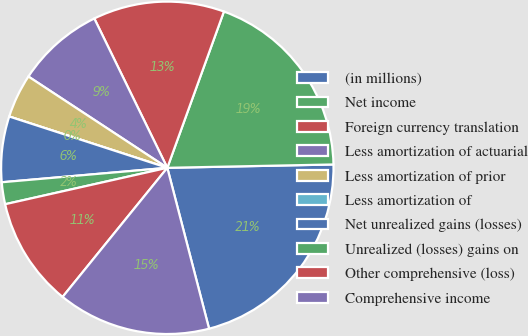Convert chart to OTSL. <chart><loc_0><loc_0><loc_500><loc_500><pie_chart><fcel>(in millions)<fcel>Net income<fcel>Foreign currency translation<fcel>Less amortization of actuarial<fcel>Less amortization of prior<fcel>Less amortization of<fcel>Net unrealized gains (losses)<fcel>Unrealized (losses) gains on<fcel>Other comprehensive (loss)<fcel>Comprehensive income<nl><fcel>21.28%<fcel>19.15%<fcel>12.77%<fcel>8.51%<fcel>4.26%<fcel>0.0%<fcel>6.38%<fcel>2.13%<fcel>10.64%<fcel>14.89%<nl></chart> 